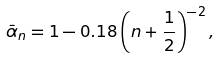<formula> <loc_0><loc_0><loc_500><loc_500>\bar { \alpha } _ { n } = 1 - 0 . 1 8 \left ( n + \frac { 1 } { 2 } \right ) ^ { - 2 } ,</formula> 